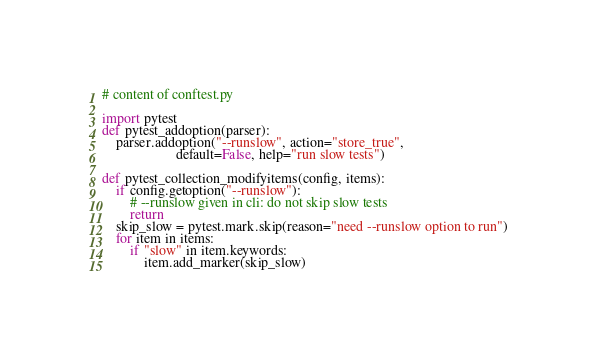<code> <loc_0><loc_0><loc_500><loc_500><_Python_># content of conftest.py

import pytest
def pytest_addoption(parser):
    parser.addoption("--runslow", action="store_true",
                     default=False, help="run slow tests")

def pytest_collection_modifyitems(config, items):
    if config.getoption("--runslow"):
        # --runslow given in cli: do not skip slow tests
        return
    skip_slow = pytest.mark.skip(reason="need --runslow option to run")
    for item in items:
        if "slow" in item.keywords:
            item.add_marker(skip_slow)
</code> 